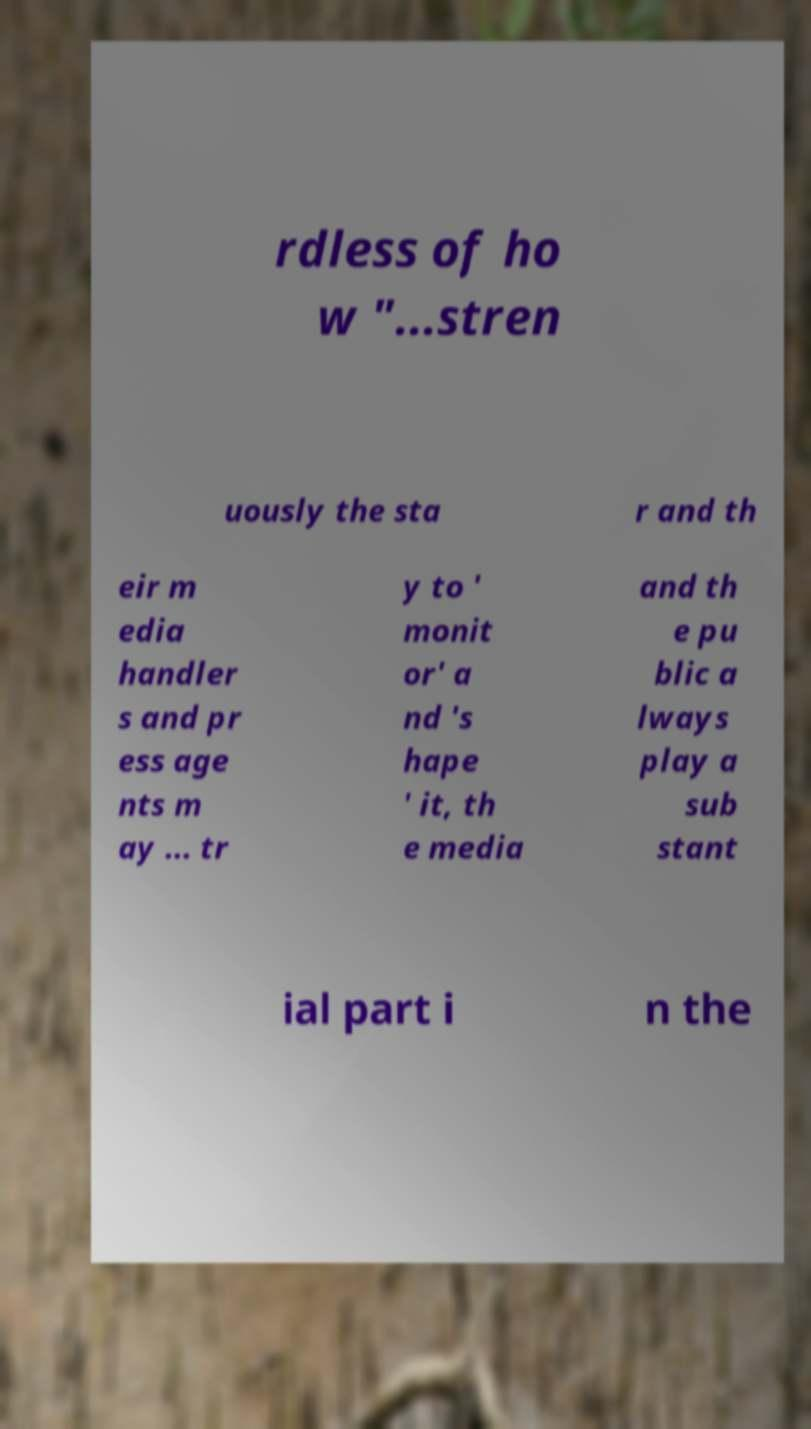Please identify and transcribe the text found in this image. rdless of ho w "...stren uously the sta r and th eir m edia handler s and pr ess age nts m ay ... tr y to ' monit or' a nd 's hape ' it, th e media and th e pu blic a lways play a sub stant ial part i n the 